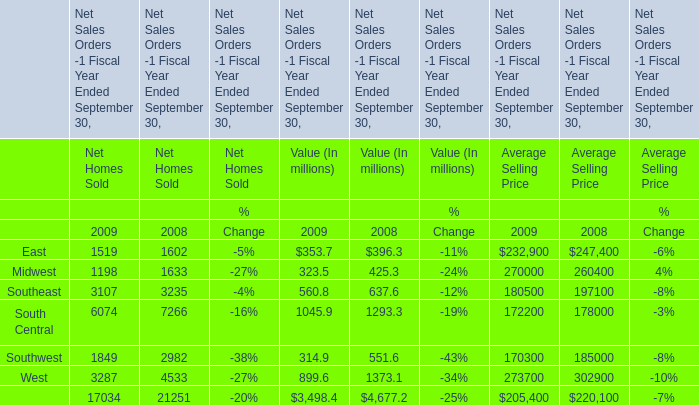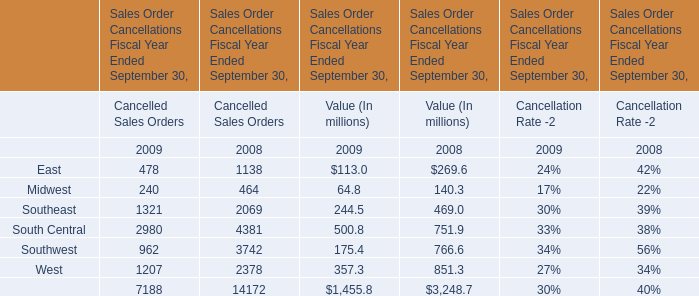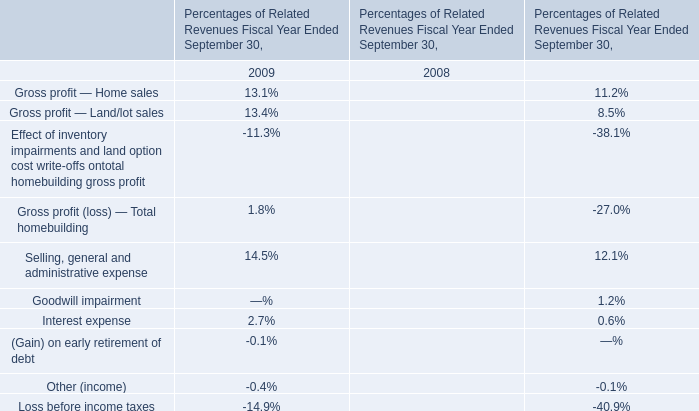In the year with lowest amount of Midwest for Value (In millions) , what's the increasing rate of South Central for Value (In millions) ? 
Computations: ((500.8 - 751.9) / 751.9)
Answer: -0.33395. 